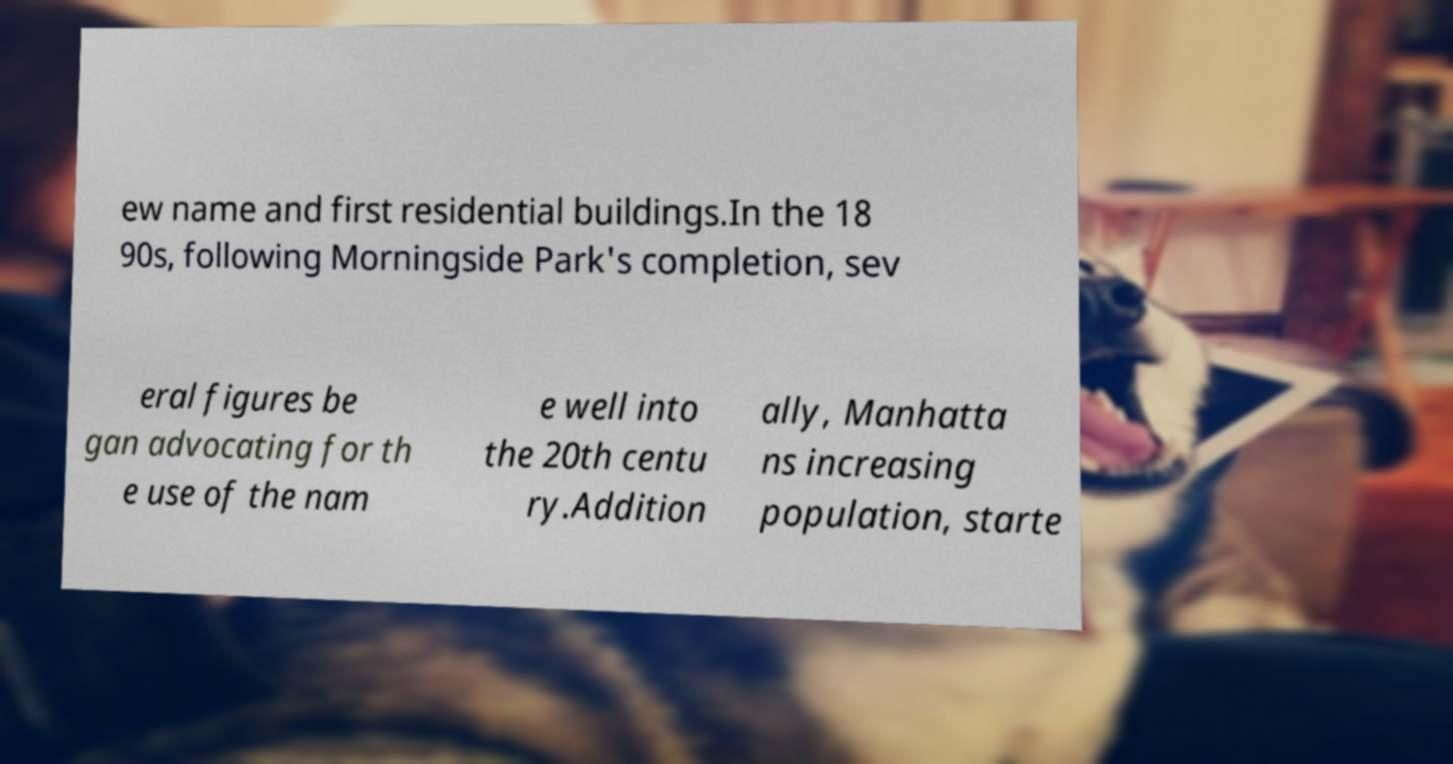Please identify and transcribe the text found in this image. ew name and first residential buildings.In the 18 90s, following Morningside Park's completion, sev eral figures be gan advocating for th e use of the nam e well into the 20th centu ry.Addition ally, Manhatta ns increasing population, starte 